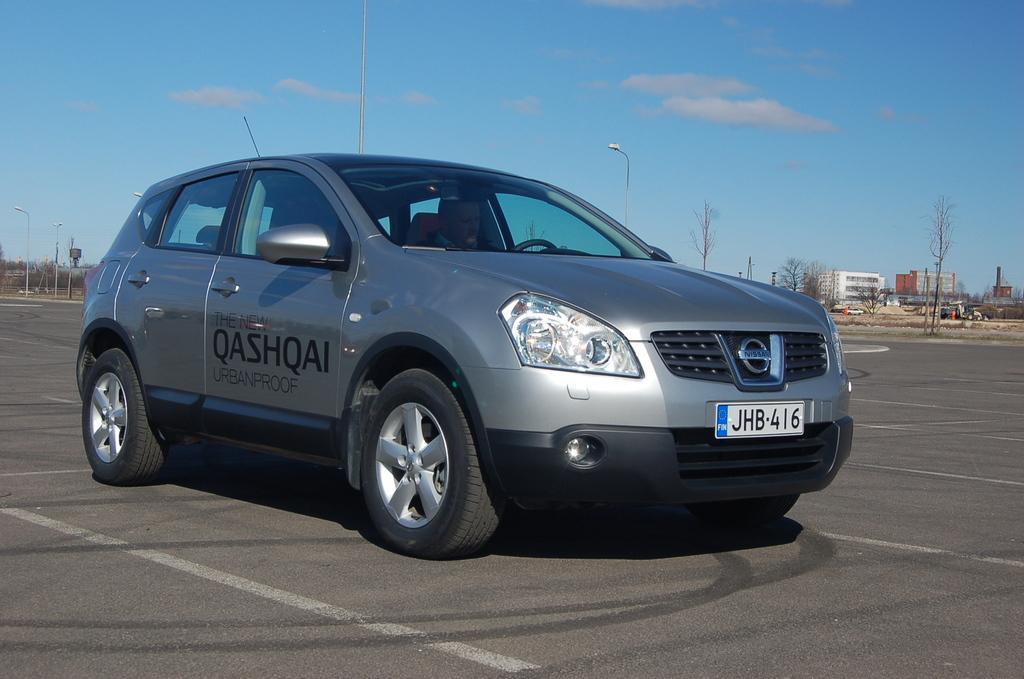How would you summarize this image in a sentence or two? In the image there is a car on the road and behind the car there are some trees and buildings. 